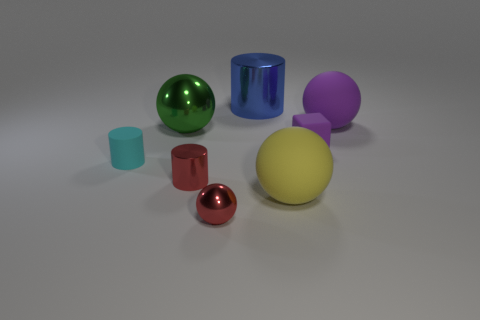Add 1 cyan shiny spheres. How many objects exist? 9 Subtract all cylinders. How many objects are left? 5 Add 4 tiny blue cylinders. How many tiny blue cylinders exist? 4 Subtract 0 brown cylinders. How many objects are left? 8 Subtract all large yellow things. Subtract all yellow rubber balls. How many objects are left? 6 Add 3 rubber balls. How many rubber balls are left? 5 